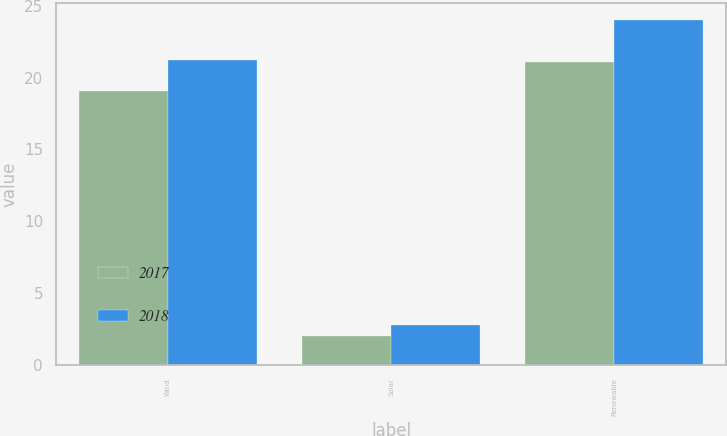Convert chart. <chart><loc_0><loc_0><loc_500><loc_500><stacked_bar_chart><ecel><fcel>Wind<fcel>Solar<fcel>Renewable<nl><fcel>2017<fcel>19.1<fcel>2<fcel>21.1<nl><fcel>2018<fcel>21.2<fcel>2.8<fcel>24<nl></chart> 